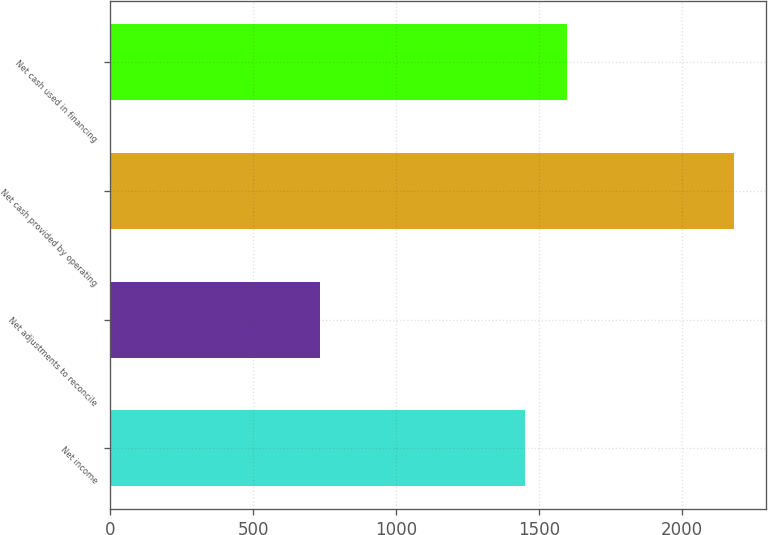<chart> <loc_0><loc_0><loc_500><loc_500><bar_chart><fcel>Net income<fcel>Net adjustments to reconcile<fcel>Net cash provided by operating<fcel>Net cash used in financing<nl><fcel>1452<fcel>732<fcel>2184<fcel>1597.2<nl></chart> 